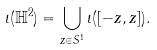<formula> <loc_0><loc_0><loc_500><loc_500>\iota ( \mathbb { H } ^ { 2 } ) = \bigcup _ { z \in S ^ { 1 } } \iota ( [ - z , z ] ) .</formula> 